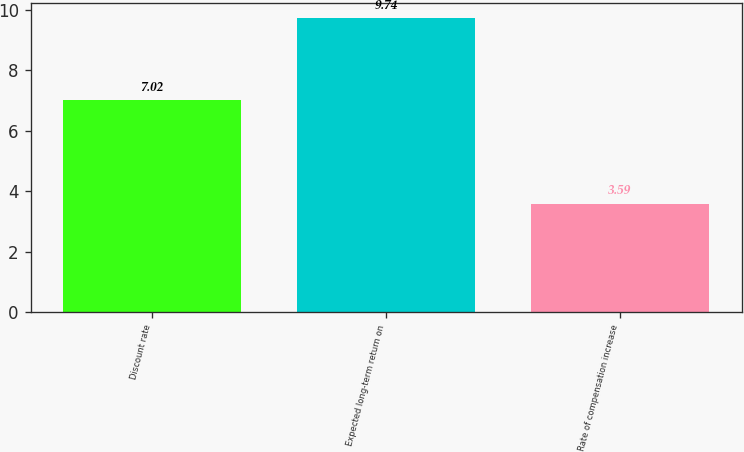Convert chart. <chart><loc_0><loc_0><loc_500><loc_500><bar_chart><fcel>Discount rate<fcel>Expected long-term return on<fcel>Rate of compensation increase<nl><fcel>7.02<fcel>9.74<fcel>3.59<nl></chart> 